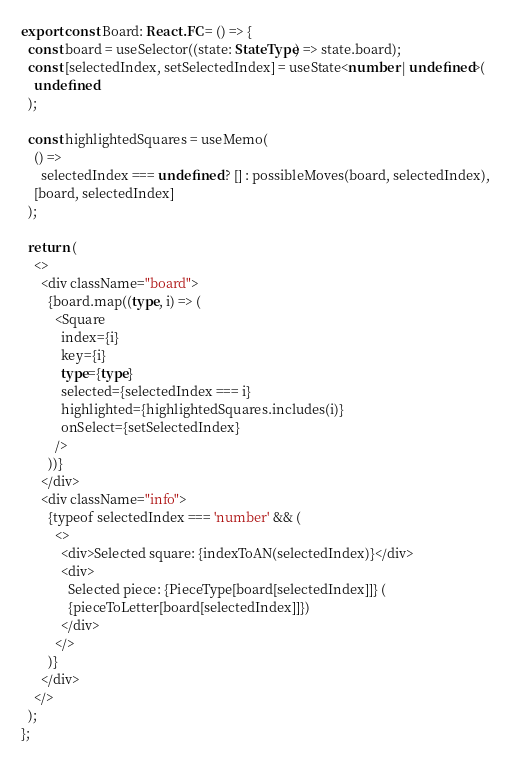Convert code to text. <code><loc_0><loc_0><loc_500><loc_500><_TypeScript_>
export const Board: React.FC = () => {
  const board = useSelector((state: StateType) => state.board);
  const [selectedIndex, setSelectedIndex] = useState<number | undefined>(
    undefined
  );

  const highlightedSquares = useMemo(
    () =>
      selectedIndex === undefined ? [] : possibleMoves(board, selectedIndex),
    [board, selectedIndex]
  );

  return (
    <>
      <div className="board">
        {board.map((type, i) => (
          <Square
            index={i}
            key={i}
            type={type}
            selected={selectedIndex === i}
            highlighted={highlightedSquares.includes(i)}
            onSelect={setSelectedIndex}
          />
        ))}
      </div>
      <div className="info">
        {typeof selectedIndex === 'number' && (
          <>
            <div>Selected square: {indexToAN(selectedIndex)}</div>
            <div>
              Selected piece: {PieceType[board[selectedIndex]]} (
              {pieceToLetter[board[selectedIndex]]})
            </div>
          </>
        )}
      </div>
    </>
  );
};
</code> 